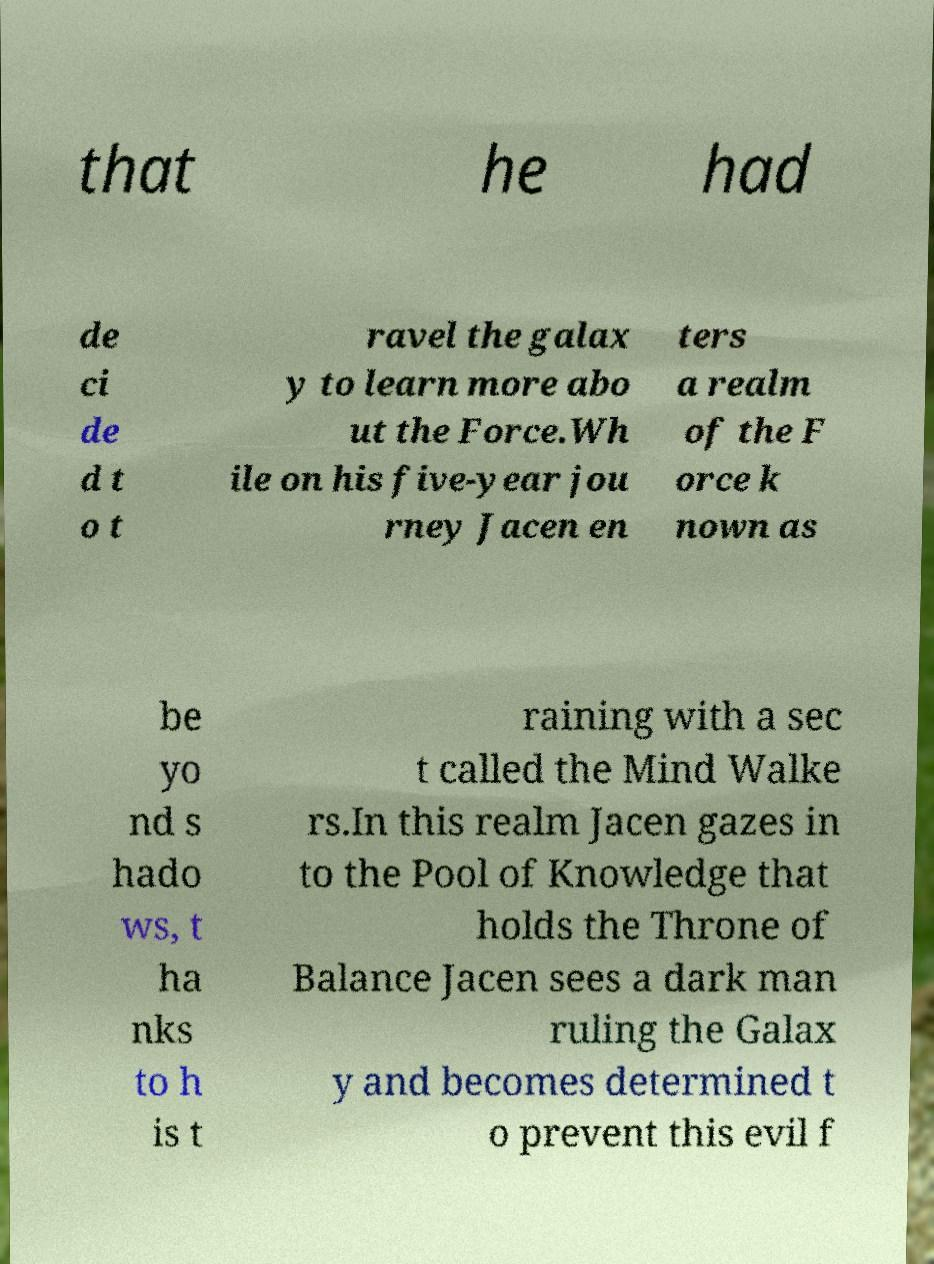Please read and relay the text visible in this image. What does it say? that he had de ci de d t o t ravel the galax y to learn more abo ut the Force.Wh ile on his five-year jou rney Jacen en ters a realm of the F orce k nown as be yo nd s hado ws, t ha nks to h is t raining with a sec t called the Mind Walke rs.In this realm Jacen gazes in to the Pool of Knowledge that holds the Throne of Balance Jacen sees a dark man ruling the Galax y and becomes determined t o prevent this evil f 